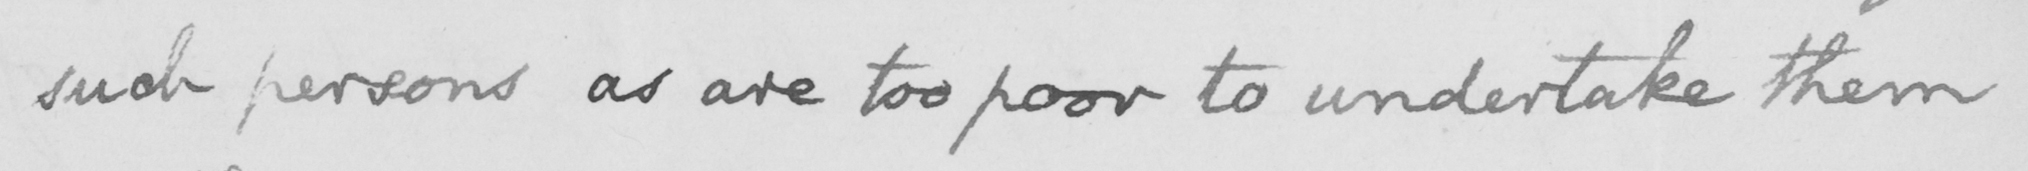Can you tell me what this handwritten text says? such persons as are too poor to undertake them 